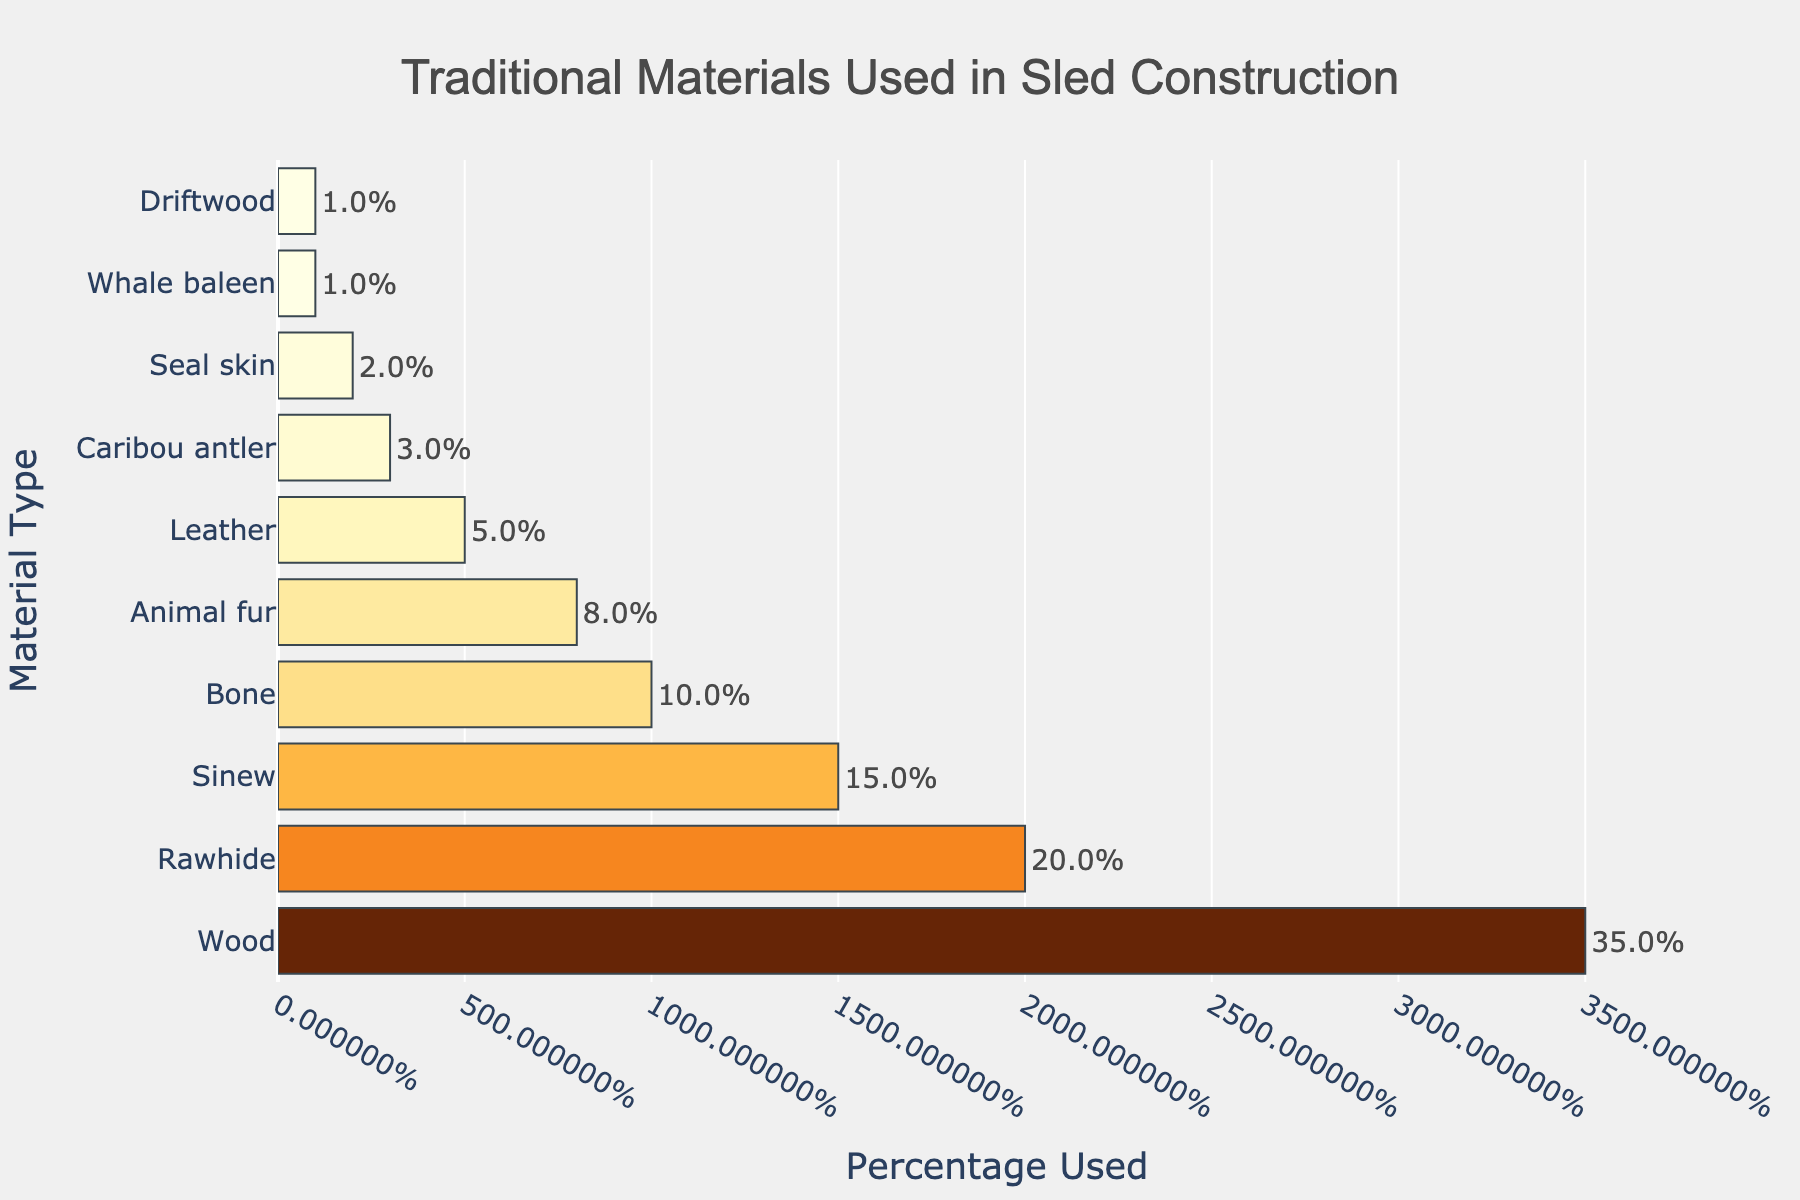Which material is used the most in traditional sled construction? According to the bar chart, Wood is shown to be the most used material with the highest percentage bar of 35%.
Answer: Wood Which two materials have the closest usage percentage? Rawhide is used 20% and Sinew is used 15%, making their percentages the closest among any two materials.
Answer: Rawhide and Sinew How much more percentage is Wood used compared to Bone? Wood is used 35%, and Bone is used 10%, so the difference in usage percentage is 35% - 10% = 25%.
Answer: 25% What is the combined percentage usage of materials derived from animals (Rawhide, Sinew, Bone, Animal fur, Leather, Caribou antler, Seal skin, Whale baleen)? The combined usage is 20% (Rawhide) + 15% (Sinew) + 10% (Bone) + 8% (Animal fur) + 5% (Leather) + 3% (Caribou antler) + 2% (Seal skin) + 1% (Whale baleen) = 64%.
Answer: 64% Which material is used the least, and what percentage does it account for? Both Whale Baleen and Driftwood are used the least, each accounting for 1% in the bar chart.
Answer: Whale baleen and Driftwood How does the percentage usage of Rawhide compare to that of Leather? Rawhide usage is 20%, while Leather usage is 5%, so Rawhide is used 4 times more than Leather.
Answer: 4 times What is the average percentage usage of all listed materials? To find the average, sum all the percentages and divide by the number of materials: (35+20+15+10+8+5+3+2+1+1) / 10 = 100/10 = 10%.
Answer: 10% Which material type's bar is roughly half as tall as the Animal fur bar? Bone is used 10%, which is roughly half of Animal fur, which is used 8%, making the bars visually comparable.
Answer: Bone 